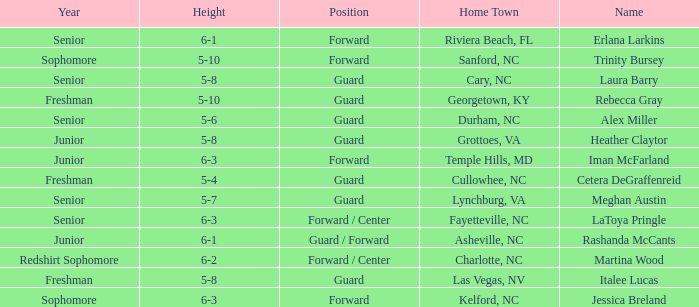In what year of school is the forward Iman McFarland? Junior. 